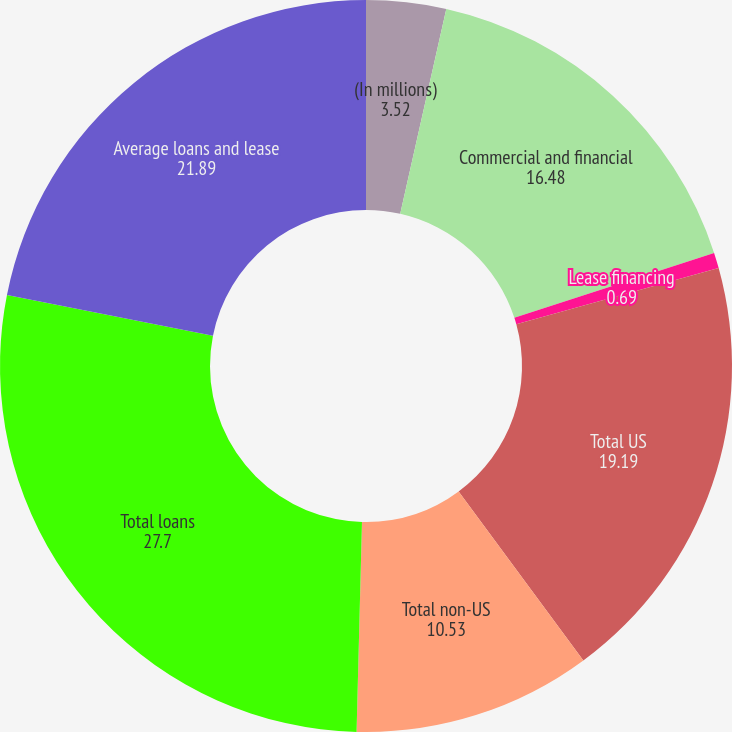Convert chart. <chart><loc_0><loc_0><loc_500><loc_500><pie_chart><fcel>(In millions)<fcel>Commercial and financial<fcel>Lease financing<fcel>Total US<fcel>Total non-US<fcel>Total loans<fcel>Average loans and lease<nl><fcel>3.52%<fcel>16.48%<fcel>0.69%<fcel>19.19%<fcel>10.53%<fcel>27.7%<fcel>21.89%<nl></chart> 